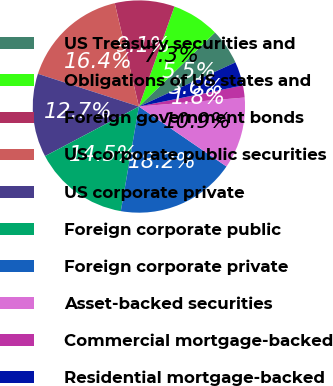<chart> <loc_0><loc_0><loc_500><loc_500><pie_chart><fcel>US Treasury securities and<fcel>Obligations of US states and<fcel>Foreign government bonds<fcel>US corporate public securities<fcel>US corporate private<fcel>Foreign corporate public<fcel>Foreign corporate private<fcel>Asset-backed securities<fcel>Commercial mortgage-backed<fcel>Residential mortgage-backed<nl><fcel>5.46%<fcel>7.28%<fcel>9.09%<fcel>16.36%<fcel>12.72%<fcel>14.54%<fcel>18.17%<fcel>10.91%<fcel>1.83%<fcel>3.64%<nl></chart> 